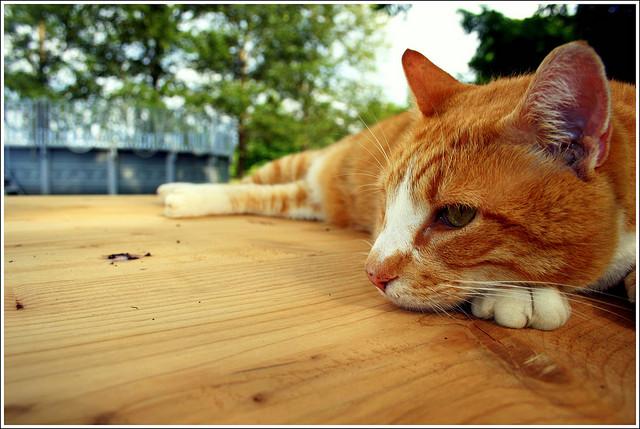Which animal is this?
Keep it brief. Cat. Is this cat outside?
Give a very brief answer. Yes. What is that in the background?
Be succinct. Pool. 